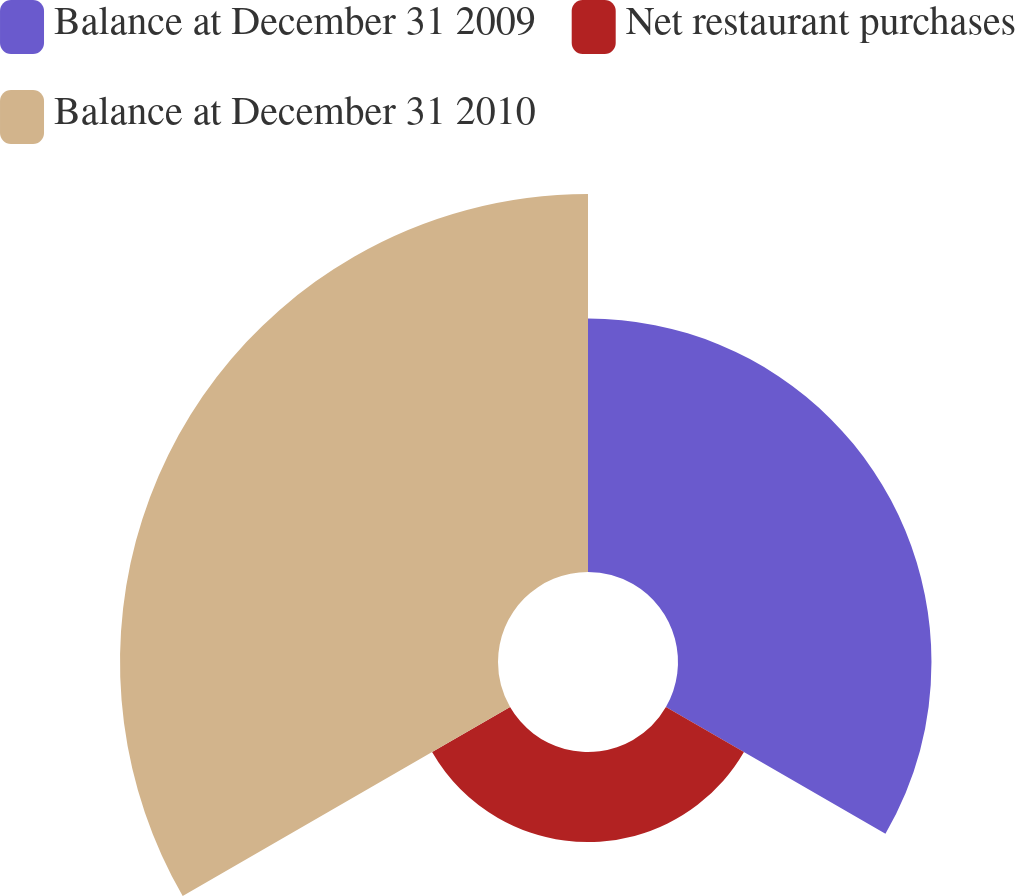<chart> <loc_0><loc_0><loc_500><loc_500><pie_chart><fcel>Balance at December 31 2009<fcel>Net restaurant purchases<fcel>Balance at December 31 2010<nl><fcel>35.13%<fcel>12.48%<fcel>52.39%<nl></chart> 